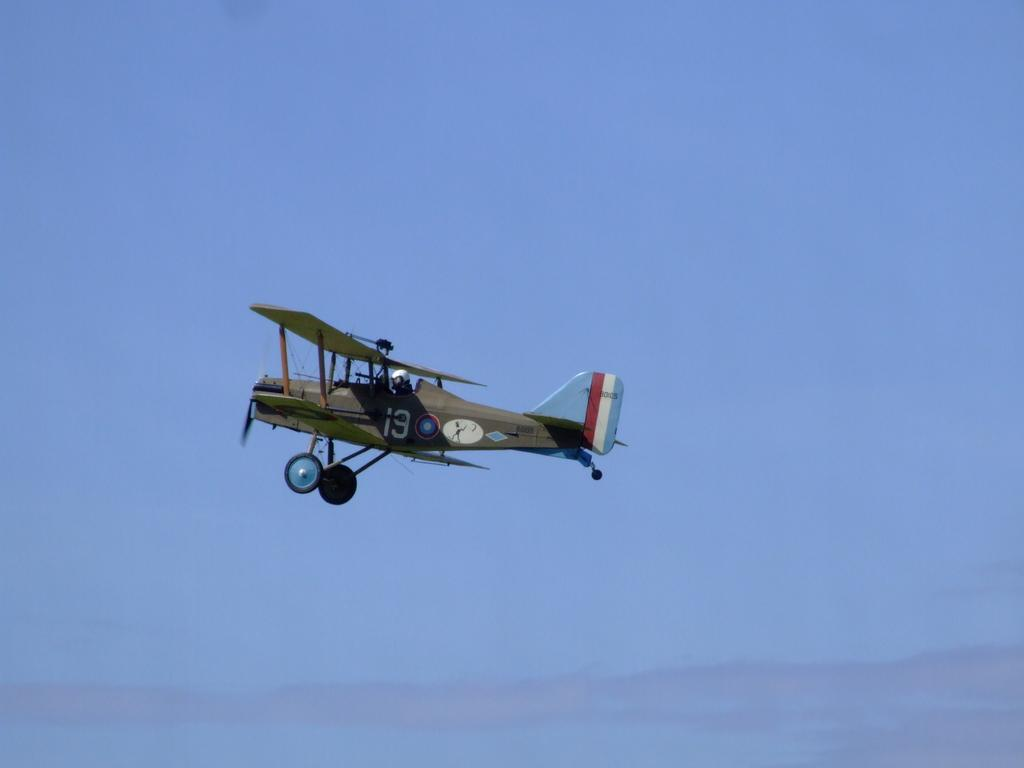Where was the picture taken? The picture is clicked outside. Who is present in the image? There is a person in the image. What is the person wearing? The person is wearing a helmet. What is the person doing in the image? The person is flying an aircraft. What is the location of the aircraft in the image? The aircraft is in the air. What can be seen in the background of the image? The sky is visible in the background of the image. How many health actors are present in the image? There are no health actors present in the image; it features a person flying an aircraft. 